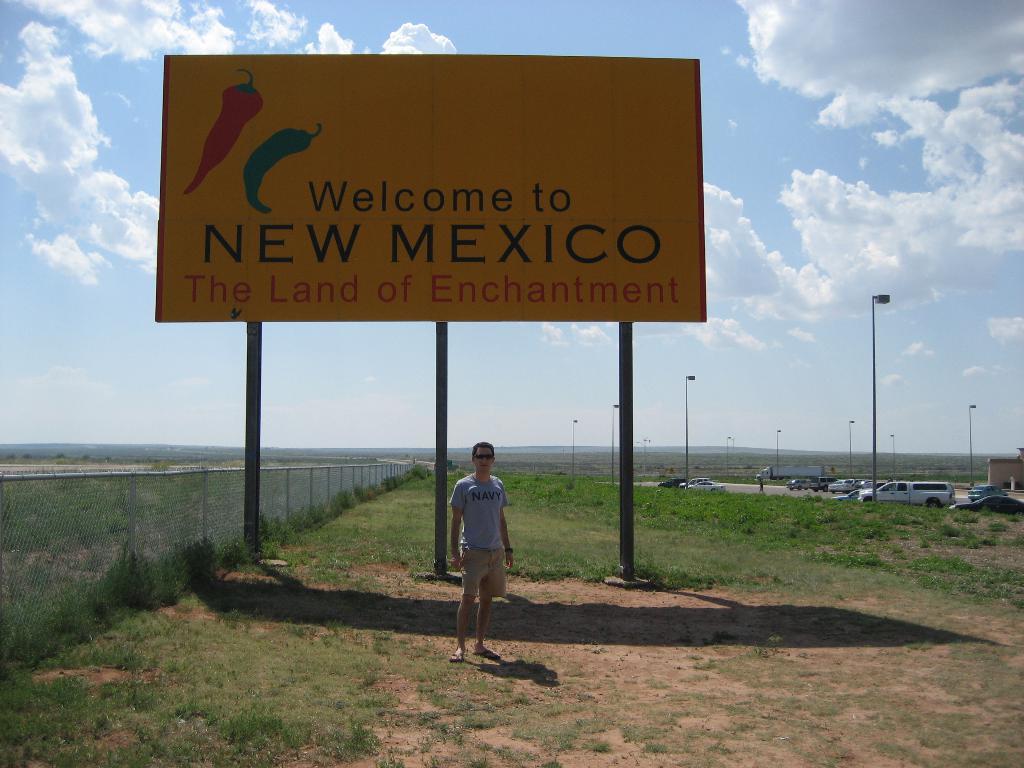Can you describe this image briefly? In this picture there is a man standing and we can see hoarding on poles, grass and fence. We can see vehicles, lights, poles and wall. In the background of the image we can see sky with clouds. 